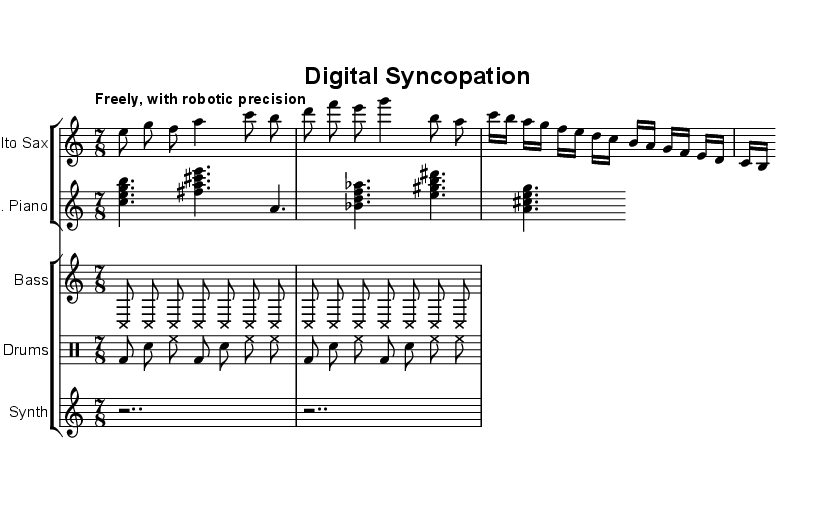What is the time signature of this music? The time signature is indicated at the beginning of the music as 7/8, meaning there are seven eighth-note beats in each measure.
Answer: 7/8 What is the tempo marking for this piece? The tempo marking is found at the beginning of the score, which instructs the performers to play "Freely, with robotic precision." This indicates the style and feel the musicians should aim for.
Answer: Freely, with robotic precision How many measures are in the alto saxophone part? By counting the number of bars in the alto saxophone line, it's evident that there are 8 measures total in that part.
Answer: 8 measures What style of music is this piece categorized under? The overall style can be inferred from the title "Digital Syncopation" and the instrumentation and themes explored, which indicate it is avant-garde jazz.
Answer: Avant-garde jazz What is the dynamic style indicated in the synthesizer part? The synthesizer part contains rests, specifically two whole rests, indicating it is silent or emphasizing a more ambient presence; however, there are no specific dynamics marked.
Answer: Rests only How is the upright bass part notated? The upright bass part is notated with cross note heads, indicating an unconventional style of playing or emphasizing the rhythmic aspect rather than pitch.
Answer: Cross note heads What unique element does the drum part incorporate? The drum part features a consistent bass drum and snare pattern with hi-hat accents, typical in jazz for creating syncopated rhythms, embodying the improvisational nature of the style.
Answer: Syncopated rhythms 